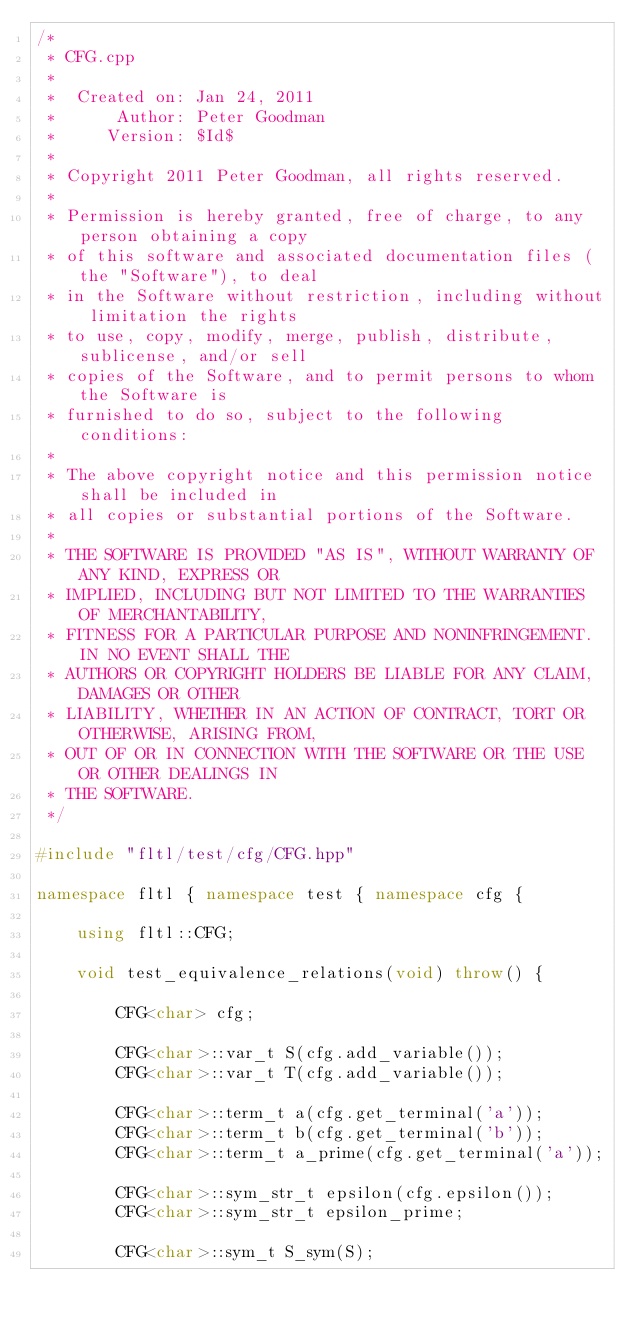Convert code to text. <code><loc_0><loc_0><loc_500><loc_500><_C++_>/*
 * CFG.cpp
 *
 *  Created on: Jan 24, 2011
 *      Author: Peter Goodman
 *     Version: $Id$
 *
 * Copyright 2011 Peter Goodman, all rights reserved.
 *
 * Permission is hereby granted, free of charge, to any person obtaining a copy
 * of this software and associated documentation files (the "Software"), to deal
 * in the Software without restriction, including without limitation the rights
 * to use, copy, modify, merge, publish, distribute, sublicense, and/or sell
 * copies of the Software, and to permit persons to whom the Software is
 * furnished to do so, subject to the following conditions:
 *
 * The above copyright notice and this permission notice shall be included in
 * all copies or substantial portions of the Software.
 *
 * THE SOFTWARE IS PROVIDED "AS IS", WITHOUT WARRANTY OF ANY KIND, EXPRESS OR
 * IMPLIED, INCLUDING BUT NOT LIMITED TO THE WARRANTIES OF MERCHANTABILITY,
 * FITNESS FOR A PARTICULAR PURPOSE AND NONINFRINGEMENT. IN NO EVENT SHALL THE
 * AUTHORS OR COPYRIGHT HOLDERS BE LIABLE FOR ANY CLAIM, DAMAGES OR OTHER
 * LIABILITY, WHETHER IN AN ACTION OF CONTRACT, TORT OR OTHERWISE, ARISING FROM,
 * OUT OF OR IN CONNECTION WITH THE SOFTWARE OR THE USE OR OTHER DEALINGS IN
 * THE SOFTWARE.
 */

#include "fltl/test/cfg/CFG.hpp"

namespace fltl { namespace test { namespace cfg {

    using fltl::CFG;

    void test_equivalence_relations(void) throw() {

        CFG<char> cfg;

        CFG<char>::var_t S(cfg.add_variable());
        CFG<char>::var_t T(cfg.add_variable());

        CFG<char>::term_t a(cfg.get_terminal('a'));
        CFG<char>::term_t b(cfg.get_terminal('b'));
        CFG<char>::term_t a_prime(cfg.get_terminal('a'));

        CFG<char>::sym_str_t epsilon(cfg.epsilon());
        CFG<char>::sym_str_t epsilon_prime;

        CFG<char>::sym_t S_sym(S);</code> 